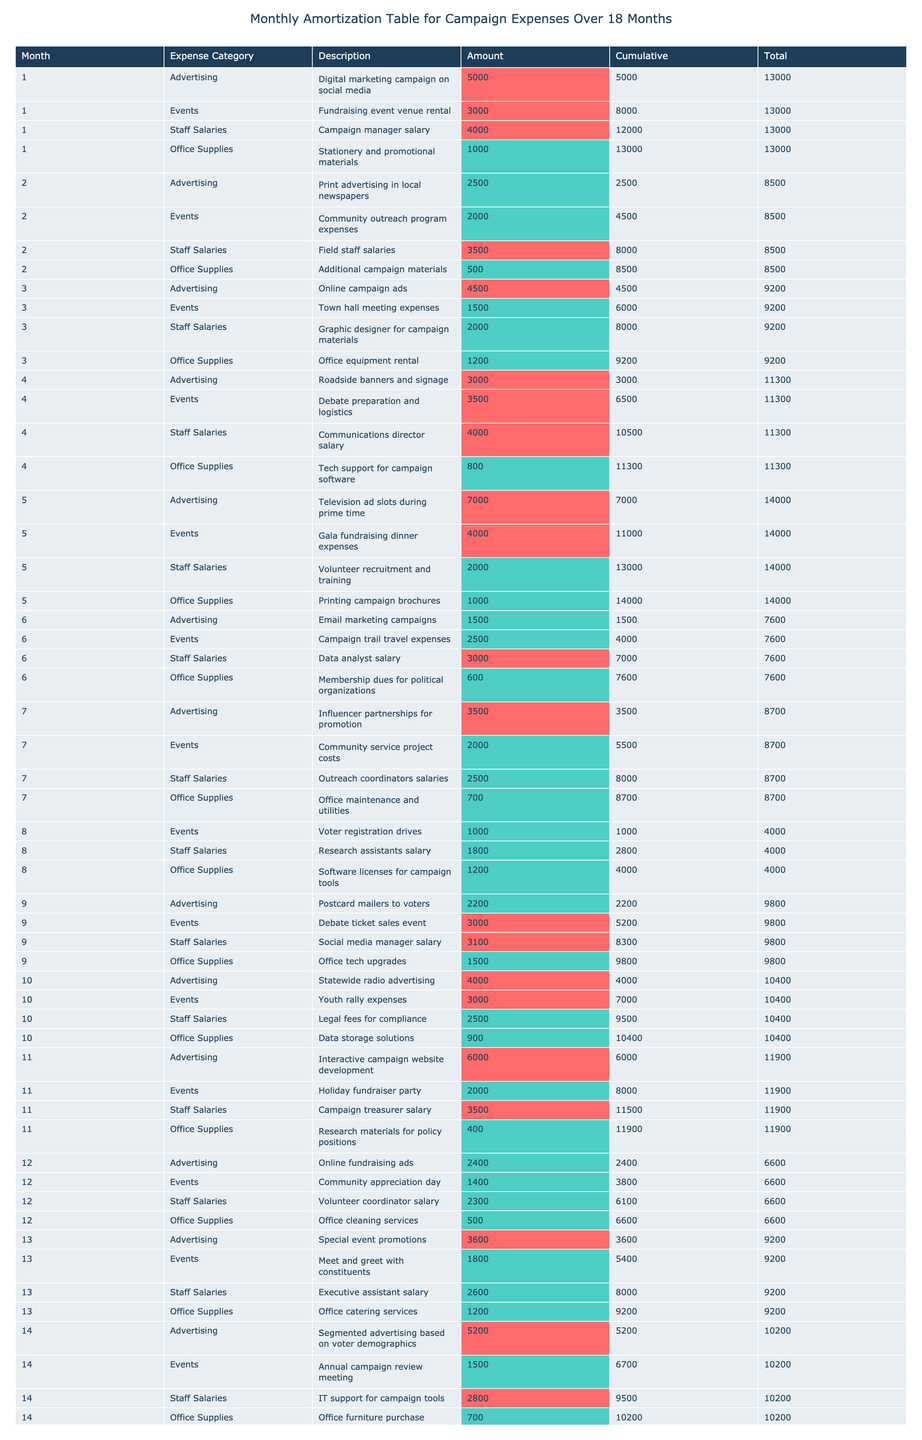What is the total expense for Month 1? For Month 1, the expenses are: Advertising: 5000, Events: 3000, Staff Salaries: 4000, and Office Supplies: 1000. Adding these amounts gives: 5000 + 3000 + 4000 + 1000 = 13000.
Answer: 13000 Which expense category has the highest total amount over the 18 months? By analyzing each expense category, the total amounts are as follows: Advertising: 47400, Events: 35800, Staff Salaries: 53000, and Office Supplies: 16400. The highest total is for Staff Salaries at 53000.
Answer: Staff Salaries In which month did the campaign incur the lowest expenses? Looking at the total expenses for each month, the lowest recorded expense is 8200 in Month 8.
Answer: Month 8 What is the average expense amount for the Events category over the campaign period? The total amount for the Events category is 35800, and there are 18 data points since a new expense is recorded each month, giving an average of 35800 / 18 = 1988.89.
Answer: 1988.89 Did the campaign spend more than 6000 on advertising in any month? Reviewing the amounts for the Advertising category, Months 5, 11, 14, 15, and 18 have expenses above 6000. Thus, it is true that there were months exceeding this threshold.
Answer: Yes What is the total amount spent on Staff Salaries in the last three months? The Staff Salaries for the last three months (Month 16, 17, and 18) are: Month 16: 3100, Month 17: 2900, Month 18: 5000. Adding these gives 3100 + 2900 + 5000 = 11000.
Answer: 11000 How much did the campaign spend exclusively on Office Supplies in Month 12? For Month 12, the amount for Office Supplies is specifically listed as 500. Therefore, the campaign spent 500 on Office Supplies that month.
Answer: 500 In total, how much was spent on Advertising in the 18 months? By summing the Advertising expenses listed for all months, the total comes to 47400 after checking each month's data individually and adding.
Answer: 47400 Which month had the highest cumulative total up to that point? Cumulatively adding the expenses month by month, Month 18 has the highest cumulative amount at 158800. To ascertain this, the previous month amounts were summed leading to the final total.
Answer: Month 18 